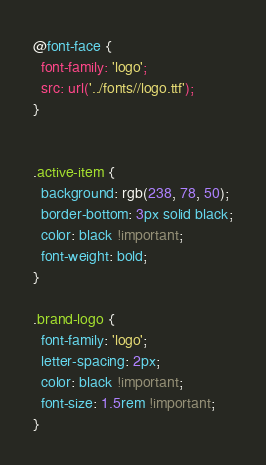<code> <loc_0><loc_0><loc_500><loc_500><_CSS_>@font-face {
  font-family: 'logo';
  src: url('../fonts//logo.ttf');
}


.active-item {
  background: rgb(238, 78, 50);
  border-bottom: 3px solid black;
  color: black !important;
  font-weight: bold;
}

.brand-logo {
  font-family: 'logo';
  letter-spacing: 2px;
  color: black !important;
  font-size: 1.5rem !important;
}</code> 